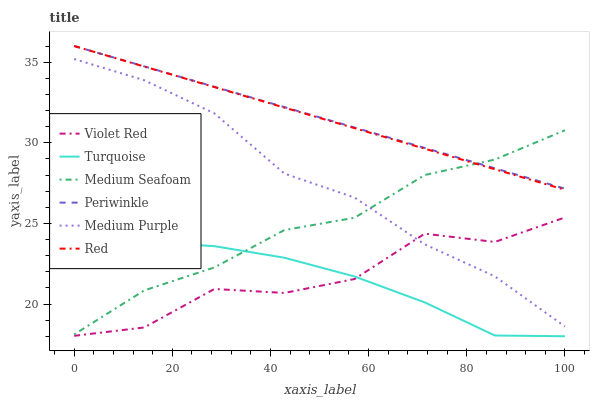Does Turquoise have the minimum area under the curve?
Answer yes or no. Yes. Does Periwinkle have the maximum area under the curve?
Answer yes or no. Yes. Does Medium Purple have the minimum area under the curve?
Answer yes or no. No. Does Medium Purple have the maximum area under the curve?
Answer yes or no. No. Is Periwinkle the smoothest?
Answer yes or no. Yes. Is Violet Red the roughest?
Answer yes or no. Yes. Is Turquoise the smoothest?
Answer yes or no. No. Is Turquoise the roughest?
Answer yes or no. No. Does Medium Purple have the lowest value?
Answer yes or no. No. Does Red have the highest value?
Answer yes or no. Yes. Does Medium Purple have the highest value?
Answer yes or no. No. Is Medium Purple less than Periwinkle?
Answer yes or no. Yes. Is Medium Purple greater than Turquoise?
Answer yes or no. Yes. Does Medium Seafoam intersect Red?
Answer yes or no. Yes. Is Medium Seafoam less than Red?
Answer yes or no. No. Is Medium Seafoam greater than Red?
Answer yes or no. No. Does Medium Purple intersect Periwinkle?
Answer yes or no. No. 